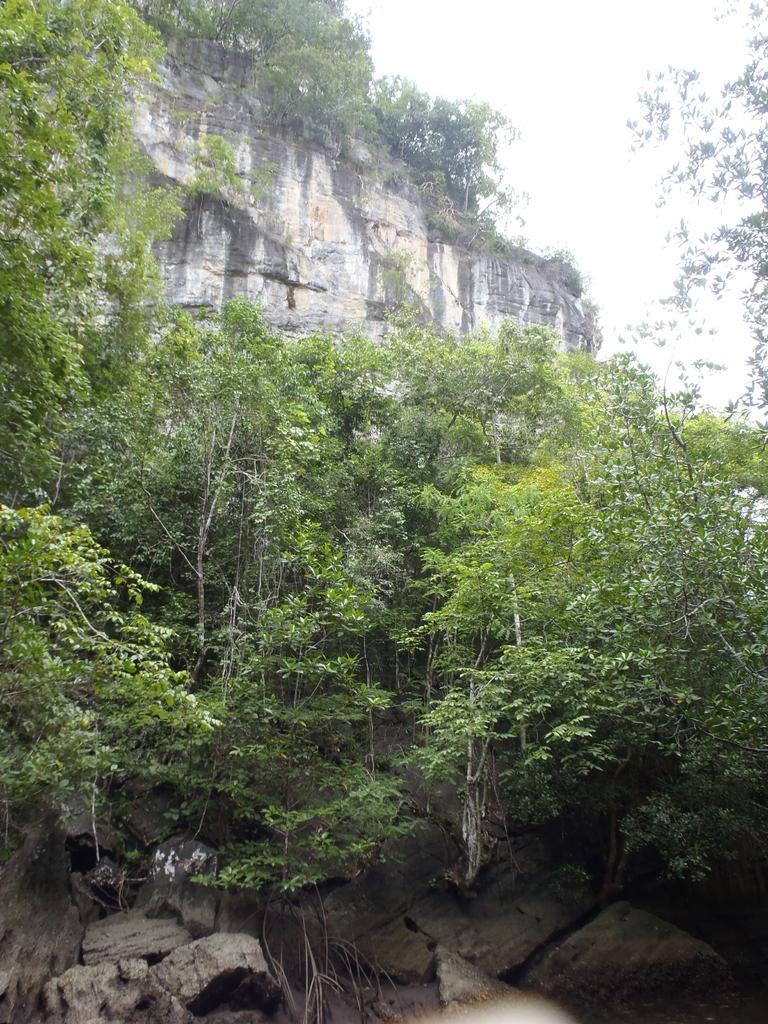Could you give a brief overview of what you see in this image? In this picture I can see the mountains. In the center I can see many trees. In the top right I can see the sky. At the bottom I can see some stones. 